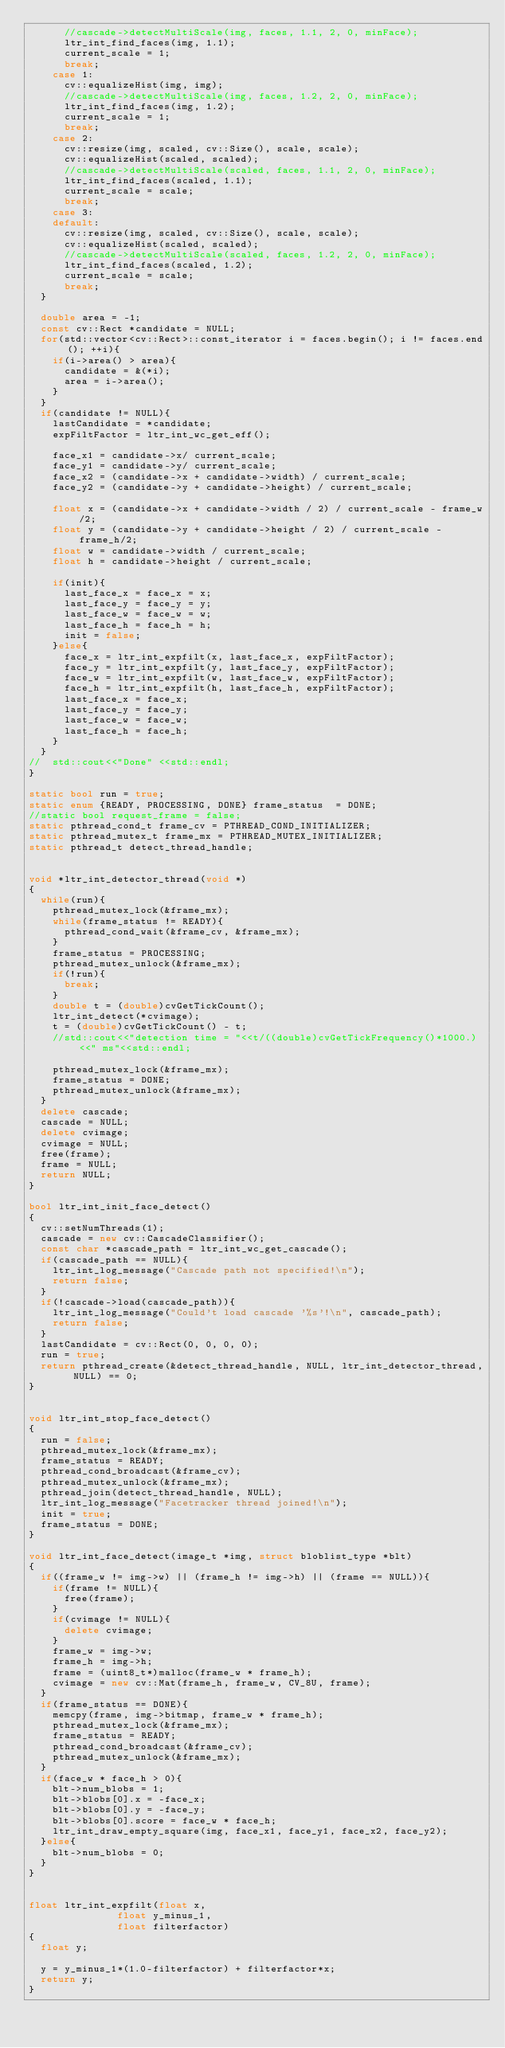Convert code to text. <code><loc_0><loc_0><loc_500><loc_500><_C++_>      //cascade->detectMultiScale(img, faces, 1.1, 2, 0, minFace);
      ltr_int_find_faces(img, 1.1);
      current_scale = 1;
      break;
    case 1:
      cv::equalizeHist(img, img);
      //cascade->detectMultiScale(img, faces, 1.2, 2, 0, minFace);
      ltr_int_find_faces(img, 1.2);
      current_scale = 1;
      break;
    case 2:
      cv::resize(img, scaled, cv::Size(), scale, scale);
      cv::equalizeHist(scaled, scaled);
      //cascade->detectMultiScale(scaled, faces, 1.1, 2, 0, minFace);
      ltr_int_find_faces(scaled, 1.1);
      current_scale = scale;
      break;
    case 3:
    default:
      cv::resize(img, scaled, cv::Size(), scale, scale);
      cv::equalizeHist(scaled, scaled);
      //cascade->detectMultiScale(scaled, faces, 1.2, 2, 0, minFace);
      ltr_int_find_faces(scaled, 1.2);
      current_scale = scale;
      break;
  }

  double area = -1;
  const cv::Rect *candidate = NULL;
  for(std::vector<cv::Rect>::const_iterator i = faces.begin(); i != faces.end(); ++i){
    if(i->area() > area){
      candidate = &(*i);
      area = i->area();
    }
  }
  if(candidate != NULL){
    lastCandidate = *candidate;
    expFiltFactor = ltr_int_wc_get_eff();

    face_x1 = candidate->x/ current_scale;
    face_y1 = candidate->y/ current_scale;
    face_x2 = (candidate->x + candidate->width) / current_scale;
    face_y2 = (candidate->y + candidate->height) / current_scale;

    float x = (candidate->x + candidate->width / 2) / current_scale - frame_w/2;
    float y = (candidate->y + candidate->height / 2) / current_scale - frame_h/2;
    float w = candidate->width / current_scale;
    float h = candidate->height / current_scale;

    if(init){
      last_face_x = face_x = x;
      last_face_y = face_y = y;
      last_face_w = face_w = w;
      last_face_h = face_h = h;
      init = false;
    }else{
      face_x = ltr_int_expfilt(x, last_face_x, expFiltFactor);
      face_y = ltr_int_expfilt(y, last_face_y, expFiltFactor);
      face_w = ltr_int_expfilt(w, last_face_w, expFiltFactor);
      face_h = ltr_int_expfilt(h, last_face_h, expFiltFactor);
      last_face_x = face_x;
      last_face_y = face_y;
      last_face_w = face_w;
      last_face_h = face_h;
    }
  }
//  std::cout<<"Done" <<std::endl;
}

static bool run = true;
static enum {READY, PROCESSING, DONE} frame_status  = DONE;
//static bool request_frame = false;
static pthread_cond_t frame_cv = PTHREAD_COND_INITIALIZER;
static pthread_mutex_t frame_mx = PTHREAD_MUTEX_INITIALIZER;
static pthread_t detect_thread_handle;


void *ltr_int_detector_thread(void *)
{
  while(run){
    pthread_mutex_lock(&frame_mx);
    while(frame_status != READY){
      pthread_cond_wait(&frame_cv, &frame_mx);
    }
    frame_status = PROCESSING;
    pthread_mutex_unlock(&frame_mx);
    if(!run){
      break;
    }
    double t = (double)cvGetTickCount();
    ltr_int_detect(*cvimage);
    t = (double)cvGetTickCount() - t;
    //std::cout<<"detection time = "<<t/((double)cvGetTickFrequency()*1000.)<<" ms"<<std::endl;

    pthread_mutex_lock(&frame_mx);
    frame_status = DONE;
    pthread_mutex_unlock(&frame_mx);
  }
  delete cascade;
  cascade = NULL;
  delete cvimage;
  cvimage = NULL;
  free(frame);
  frame = NULL;
  return NULL;
}

bool ltr_int_init_face_detect()
{
  cv::setNumThreads(1);
  cascade = new cv::CascadeClassifier();
  const char *cascade_path = ltr_int_wc_get_cascade();
  if(cascade_path == NULL){
    ltr_int_log_message("Cascade path not specified!\n");
    return false;
  }
  if(!cascade->load(cascade_path)){
    ltr_int_log_message("Could't load cascade '%s'!\n", cascade_path);
    return false;
  }
  lastCandidate = cv::Rect(0, 0, 0, 0);
  run = true;
  return pthread_create(&detect_thread_handle, NULL, ltr_int_detector_thread, NULL) == 0;
}


void ltr_int_stop_face_detect()
{
  run = false;
  pthread_mutex_lock(&frame_mx);
  frame_status = READY;
  pthread_cond_broadcast(&frame_cv);
  pthread_mutex_unlock(&frame_mx);
  pthread_join(detect_thread_handle, NULL);
  ltr_int_log_message("Facetracker thread joined!\n");
  init = true;
  frame_status = DONE;
}

void ltr_int_face_detect(image_t *img, struct bloblist_type *blt)
{
  if((frame_w != img->w) || (frame_h != img->h) || (frame == NULL)){
    if(frame != NULL){
      free(frame);
    }
    if(cvimage != NULL){
      delete cvimage;
    }
    frame_w = img->w;
    frame_h = img->h;
    frame = (uint8_t*)malloc(frame_w * frame_h);
    cvimage = new cv::Mat(frame_h, frame_w, CV_8U, frame);
  }
  if(frame_status == DONE){
    memcpy(frame, img->bitmap, frame_w * frame_h);
    pthread_mutex_lock(&frame_mx);
    frame_status = READY;
    pthread_cond_broadcast(&frame_cv);
    pthread_mutex_unlock(&frame_mx);
  }
  if(face_w * face_h > 0){
    blt->num_blobs = 1;
    blt->blobs[0].x = -face_x;
    blt->blobs[0].y = -face_y;
    blt->blobs[0].score = face_w * face_h;
    ltr_int_draw_empty_square(img, face_x1, face_y1, face_x2, face_y2);
  }else{
    blt->num_blobs = 0;
  }
}


float ltr_int_expfilt(float x,
               float y_minus_1,
               float filterfactor)
{
  float y;

  y = y_minus_1*(1.0-filterfactor) + filterfactor*x;
  return y;
}

</code> 